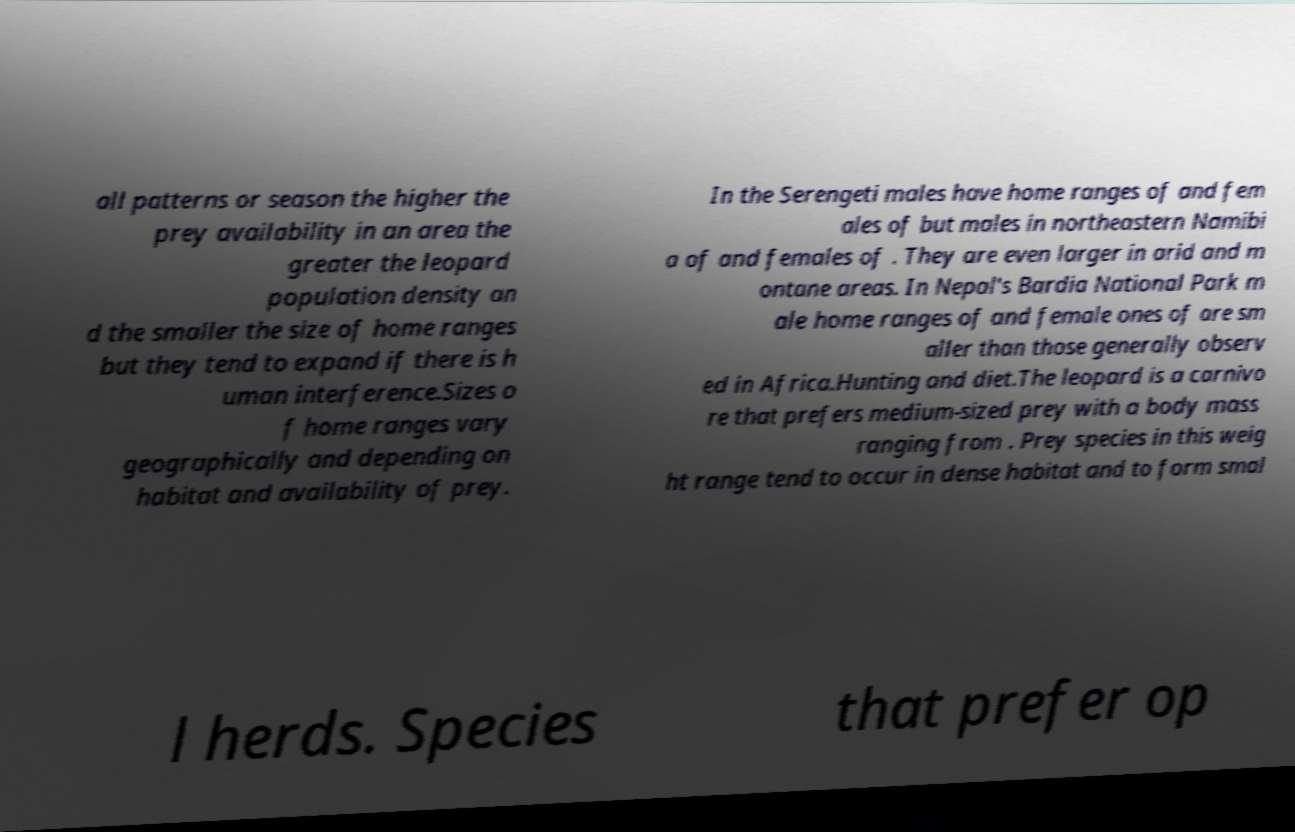Please read and relay the text visible in this image. What does it say? all patterns or season the higher the prey availability in an area the greater the leopard population density an d the smaller the size of home ranges but they tend to expand if there is h uman interference.Sizes o f home ranges vary geographically and depending on habitat and availability of prey. In the Serengeti males have home ranges of and fem ales of but males in northeastern Namibi a of and females of . They are even larger in arid and m ontane areas. In Nepal's Bardia National Park m ale home ranges of and female ones of are sm aller than those generally observ ed in Africa.Hunting and diet.The leopard is a carnivo re that prefers medium-sized prey with a body mass ranging from . Prey species in this weig ht range tend to occur in dense habitat and to form smal l herds. Species that prefer op 